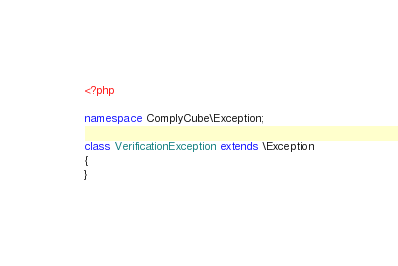<code> <loc_0><loc_0><loc_500><loc_500><_PHP_><?php

namespace ComplyCube\Exception;

class VerificationException extends \Exception
{
}
</code> 